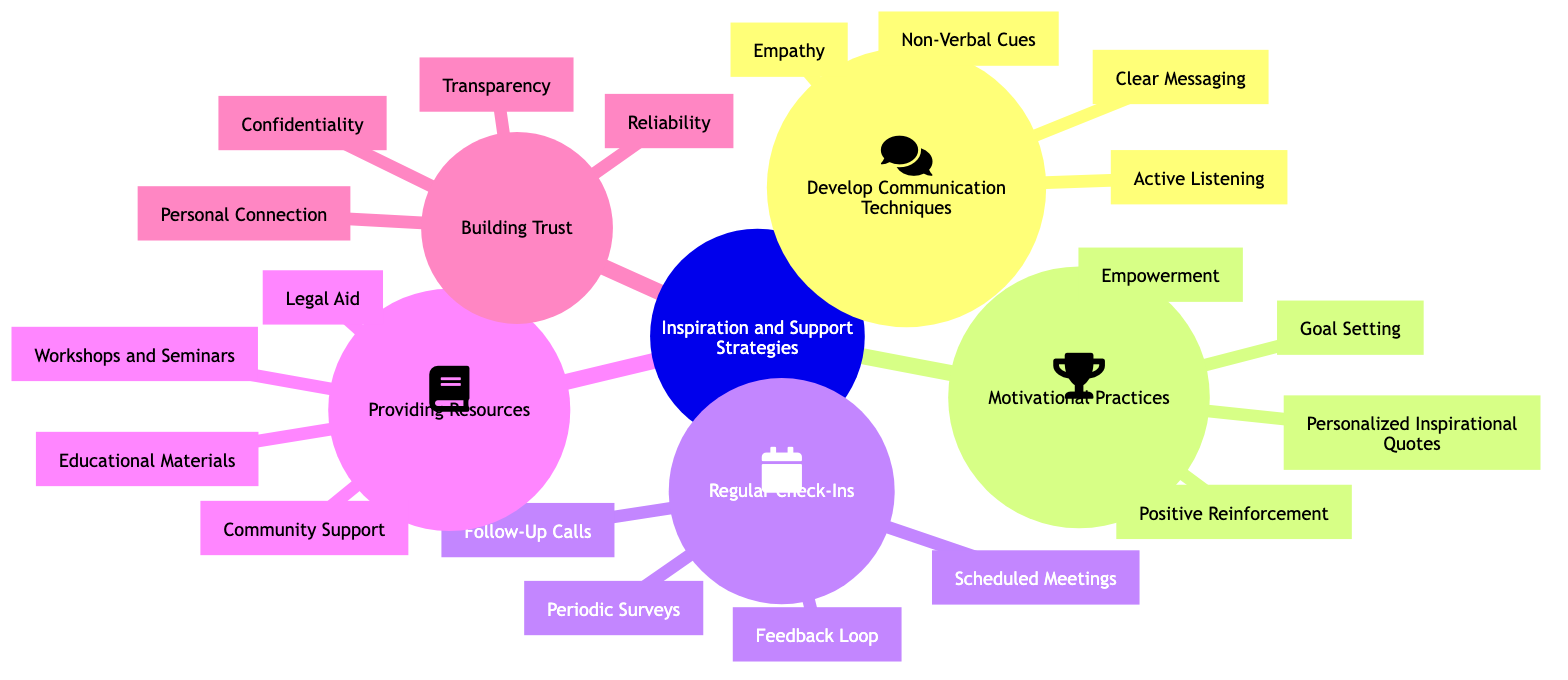What is a subcategory under "Develop Communication Techniques"? The diagram shows “Develop Communication Techniques” as a main node, with four sub-nodes, one of which is "Active Listening."
Answer: Active Listening How many main strategy categories are presented in the mind map? The diagram has five main categories: "Develop Communication Techniques," "Motivational Practices," "Regular Check-Ins," "Providing Resources," and "Building Trust." Therefore, there are five main categories in total.
Answer: 5 What is an example of a practice under "Motivational Practices"? Under "Motivational Practices," the diagram lists several techniques, including "Goal Setting" as an example of a motivational practice.
Answer: Goal Setting Which category includes "Confidentiality"? “Confidentiality” is a node under the “Building Trust” category in the diagram.
Answer: Building Trust What are the components of "Regular Check-Ins"? The "Regular Check-Ins" category contains four components: "Scheduled Meetings," "Periodic Surveys," "Follow-Up Calls," and "Feedback Loop." These are part of the strategy to ensure consistent communication.
Answer: Scheduled Meetings, Periodic Surveys, Follow-Up Calls, Feedback Loop Which two strategies are focused on supporting client motivation? The strategies “Goal Setting” and “Positive Reinforcement” both focus on client motivation as part of the category "Motivational Practices."
Answer: Goal Setting, Positive Reinforcement What aspect of the client support process does "Providing Resources" address? The "Providing Resources" category focuses on equipping clients with tools and information, including "Legal Aid," "Educational Materials," "Community Support," and "Workshops and Seminars."
Answer: Equipping clients with tools and information Which communication technique involves understanding client feelings? The diagram specifies "Empathy" as a communication technique that involves understanding and sharing the feelings of clients.
Answer: Empathy What is the primary purpose of "Follow-Up Calls"? The purpose of "Follow-Up Calls" is to ensure clients feel supported between meetings, which emphasizes the importance of continual engagement and support.
Answer: Ensure clients feel supported What does the node "Personal Connection" aim to enhance? The diagram indicates that "Personal Connection" aims to enhance the relationship between clients and their lawyer by showing genuine interest in clients' lives and well-being.
Answer: Enhance the relationship 